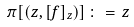Convert formula to latex. <formula><loc_0><loc_0><loc_500><loc_500>\pi [ ( z , [ f ] _ { z } ) ] \, \colon = \, z</formula> 